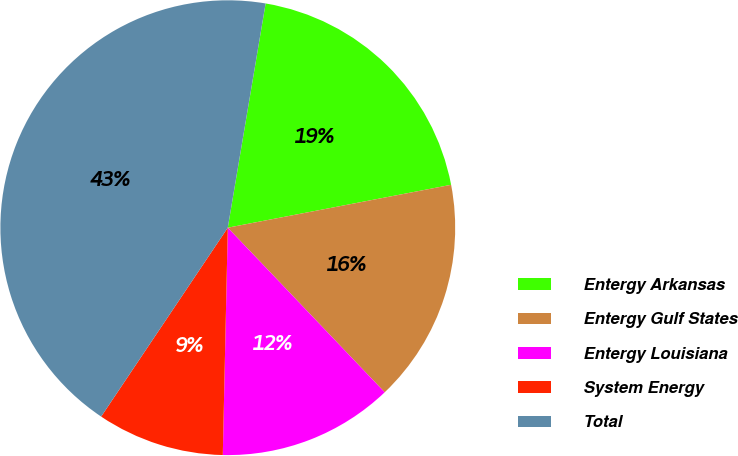<chart> <loc_0><loc_0><loc_500><loc_500><pie_chart><fcel>Entergy Arkansas<fcel>Entergy Gulf States<fcel>Entergy Louisiana<fcel>System Energy<fcel>Total<nl><fcel>19.32%<fcel>15.9%<fcel>12.47%<fcel>9.05%<fcel>43.26%<nl></chart> 